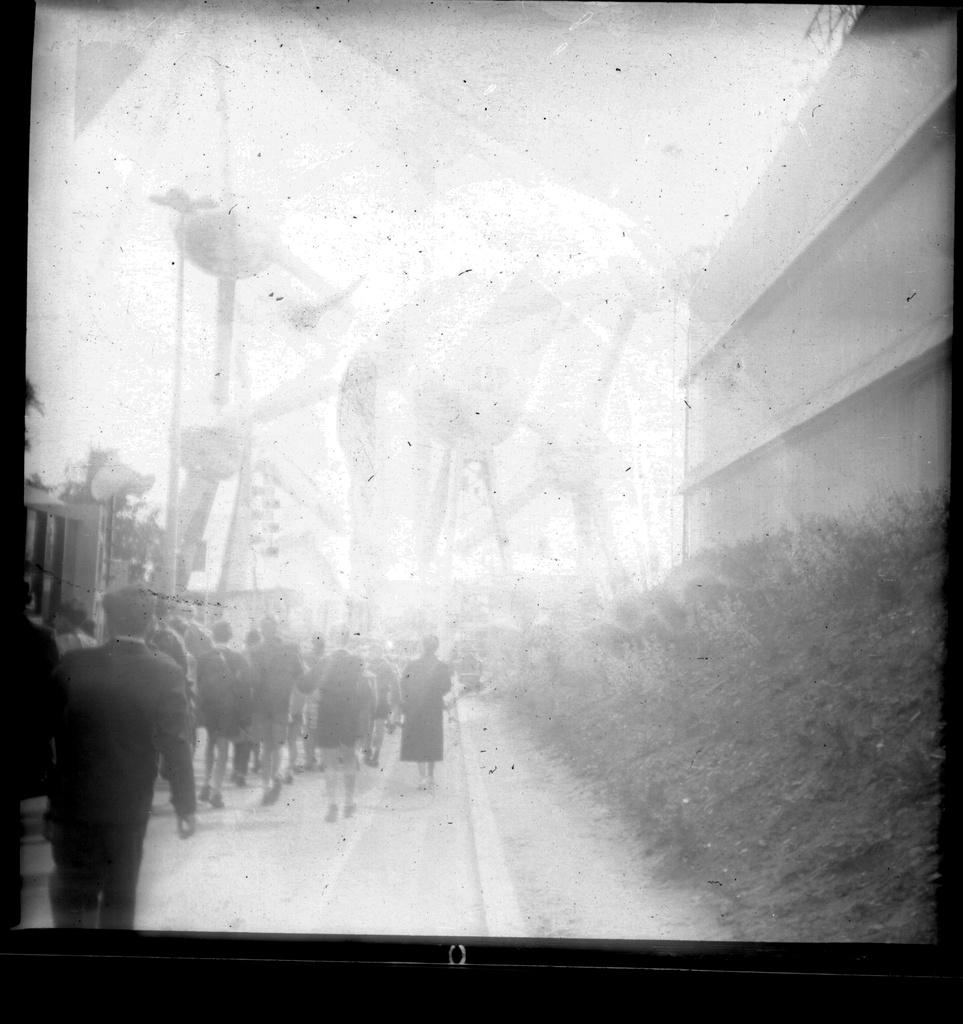What is the main object in the image? There is a screen in the image. What can be seen on the screen? The screen displays people walking on a road. How many bricks are on the road in the image? There are no bricks visible in the image. 